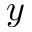<formula> <loc_0><loc_0><loc_500><loc_500>y</formula> 